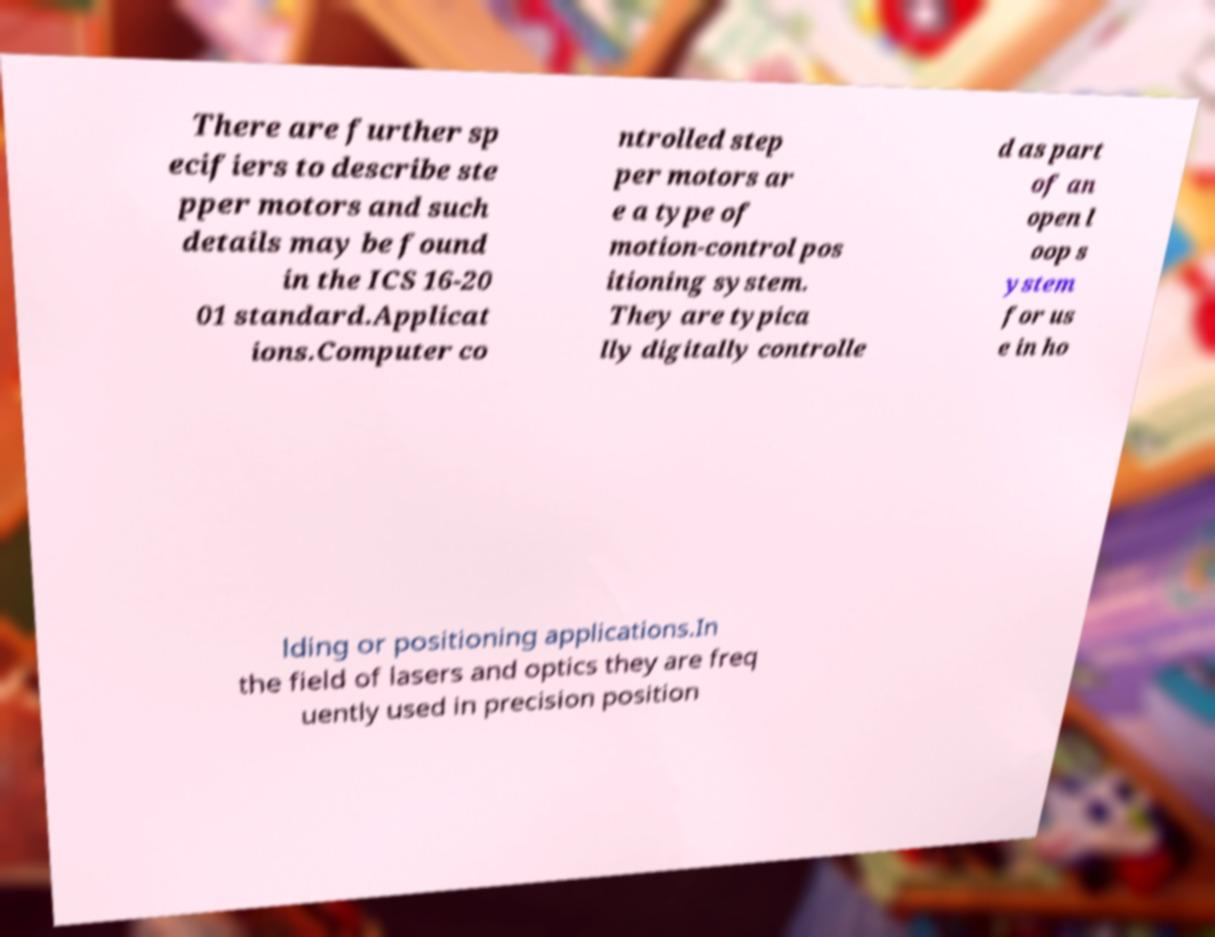Could you extract and type out the text from this image? There are further sp ecifiers to describe ste pper motors and such details may be found in the ICS 16-20 01 standard.Applicat ions.Computer co ntrolled step per motors ar e a type of motion-control pos itioning system. They are typica lly digitally controlle d as part of an open l oop s ystem for us e in ho lding or positioning applications.In the field of lasers and optics they are freq uently used in precision position 